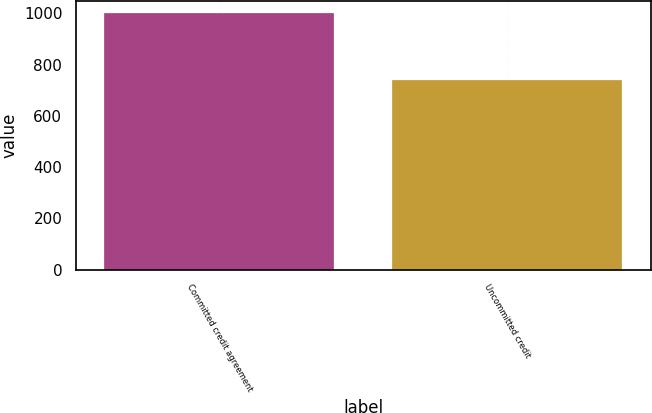<chart> <loc_0><loc_0><loc_500><loc_500><bar_chart><fcel>Committed credit agreement<fcel>Uncommitted credit<nl><fcel>1000<fcel>740.3<nl></chart> 